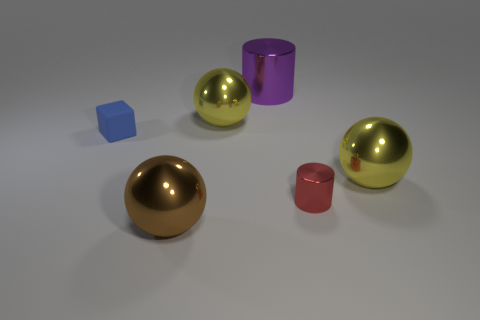What textures are apparent on the surfaces in the scene? The objects exhibit smooth and shiny surfaces that reflect the environment, indicating a metallic or glossy plastic texture. The ground displays a matte finish with a subtle texture that diffuses light, suggesting a surface similar to fine-grain sandpaper. 